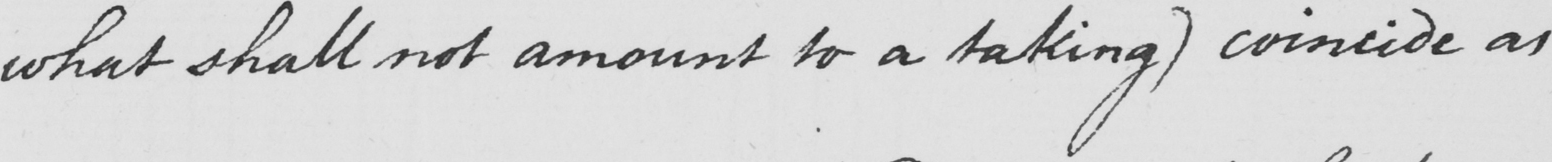Can you tell me what this handwritten text says? what shall not amount to a taking )  coincide as 